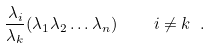Convert formula to latex. <formula><loc_0><loc_0><loc_500><loc_500>\frac { \lambda _ { i } } { \lambda _ { k } } ( \lambda _ { 1 } \lambda _ { 2 } \dots \lambda _ { n } ) \quad i \neq k \ .</formula> 